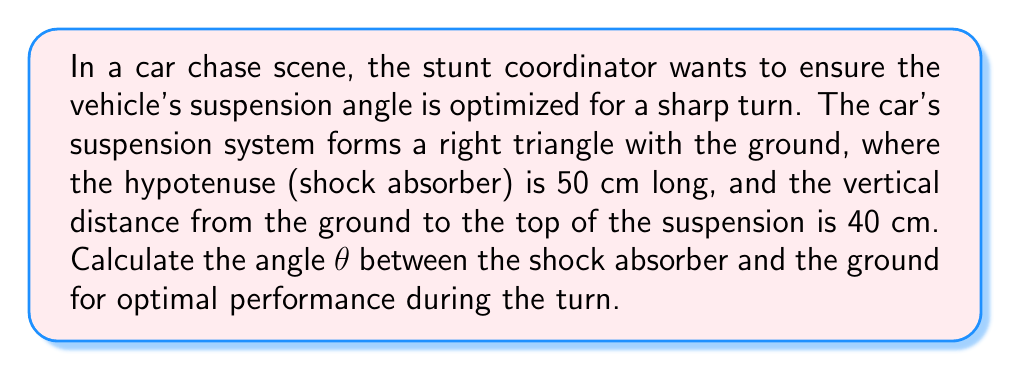Show me your answer to this math problem. To solve this problem, we'll use trigonometric ratios in a right triangle. Let's approach this step-by-step:

1. Identify the known values:
   - Hypotenuse (shock absorber length) = 50 cm
   - Opposite side (vertical distance) = 40 cm

2. Determine which trigonometric ratio to use:
   We're looking for the angle θ, and we know the opposite side and hypotenuse. This corresponds to the sine function.

3. Set up the sine equation:
   $$\sin θ = \frac{\text{opposite}}{\text{hypotenuse}} = \frac{40}{50}$$

4. Solve for θ using the inverse sine (arcsin) function:
   $$θ = \arcsin(\frac{40}{50})$$

5. Calculate the result:
   $$θ ≈ 53.13°$$

6. Round to two decimal places:
   θ ≈ 53.13°

[asy]
unitsize(2cm);
draw((0,0)--(3,0)--(3,2.4)--(0,0),black);
draw((3,0)--(3.2,0),black);
draw((3,0)--(3,0.2),black);
label("50 cm",(-0.2,1.5),W);
label("40 cm",(3.1,1.2),E);
label("θ",(0.3,0.2),NE);
[/asy]

This angle provides the optimal suspension geometry for the car's performance during the sharp turn in the chase scene.
Answer: $53.13°$ 